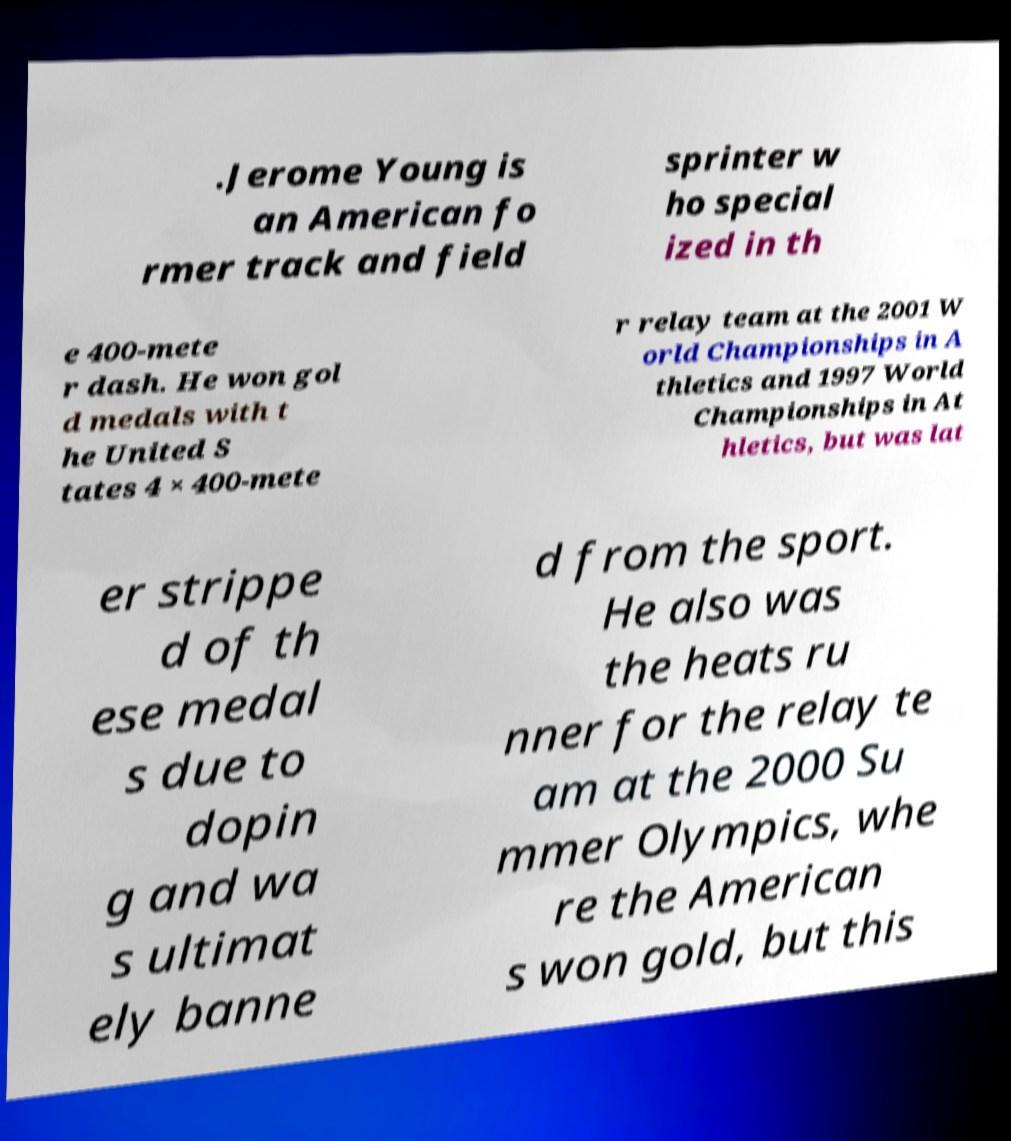Can you read and provide the text displayed in the image?This photo seems to have some interesting text. Can you extract and type it out for me? .Jerome Young is an American fo rmer track and field sprinter w ho special ized in th e 400-mete r dash. He won gol d medals with t he United S tates 4 × 400-mete r relay team at the 2001 W orld Championships in A thletics and 1997 World Championships in At hletics, but was lat er strippe d of th ese medal s due to dopin g and wa s ultimat ely banne d from the sport. He also was the heats ru nner for the relay te am at the 2000 Su mmer Olympics, whe re the American s won gold, but this 